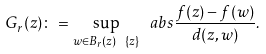<formula> <loc_0><loc_0><loc_500><loc_500>G _ { r } ( z ) \colon = \sup _ { w \in B _ { r } ( z ) \ \{ z \} } \ a b s { \frac { f ( z ) - f ( w ) } { d ( z , w ) } } .</formula> 